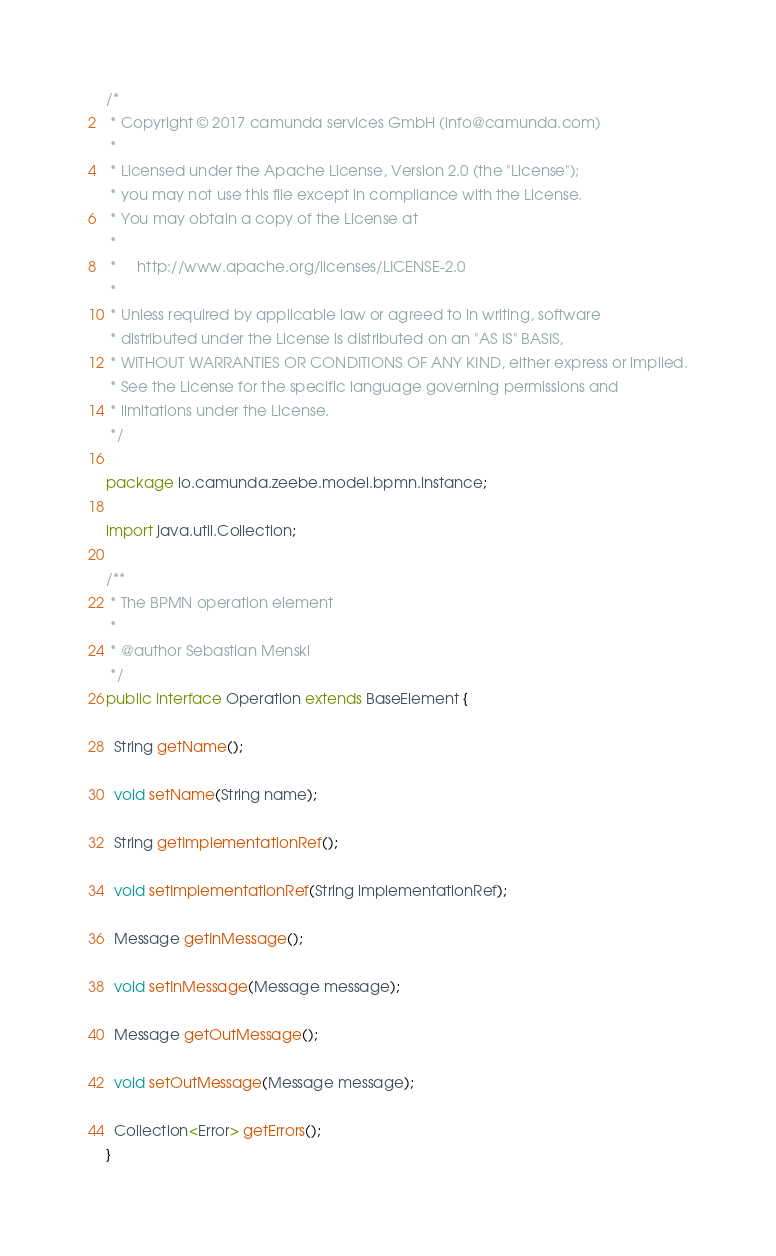Convert code to text. <code><loc_0><loc_0><loc_500><loc_500><_Java_>/*
 * Copyright © 2017 camunda services GmbH (info@camunda.com)
 *
 * Licensed under the Apache License, Version 2.0 (the "License");
 * you may not use this file except in compliance with the License.
 * You may obtain a copy of the License at
 *
 *     http://www.apache.org/licenses/LICENSE-2.0
 *
 * Unless required by applicable law or agreed to in writing, software
 * distributed under the License is distributed on an "AS IS" BASIS,
 * WITHOUT WARRANTIES OR CONDITIONS OF ANY KIND, either express or implied.
 * See the License for the specific language governing permissions and
 * limitations under the License.
 */

package io.camunda.zeebe.model.bpmn.instance;

import java.util.Collection;

/**
 * The BPMN operation element
 *
 * @author Sebastian Menski
 */
public interface Operation extends BaseElement {

  String getName();

  void setName(String name);

  String getImplementationRef();

  void setImplementationRef(String implementationRef);

  Message getInMessage();

  void setInMessage(Message message);

  Message getOutMessage();

  void setOutMessage(Message message);

  Collection<Error> getErrors();
}
</code> 